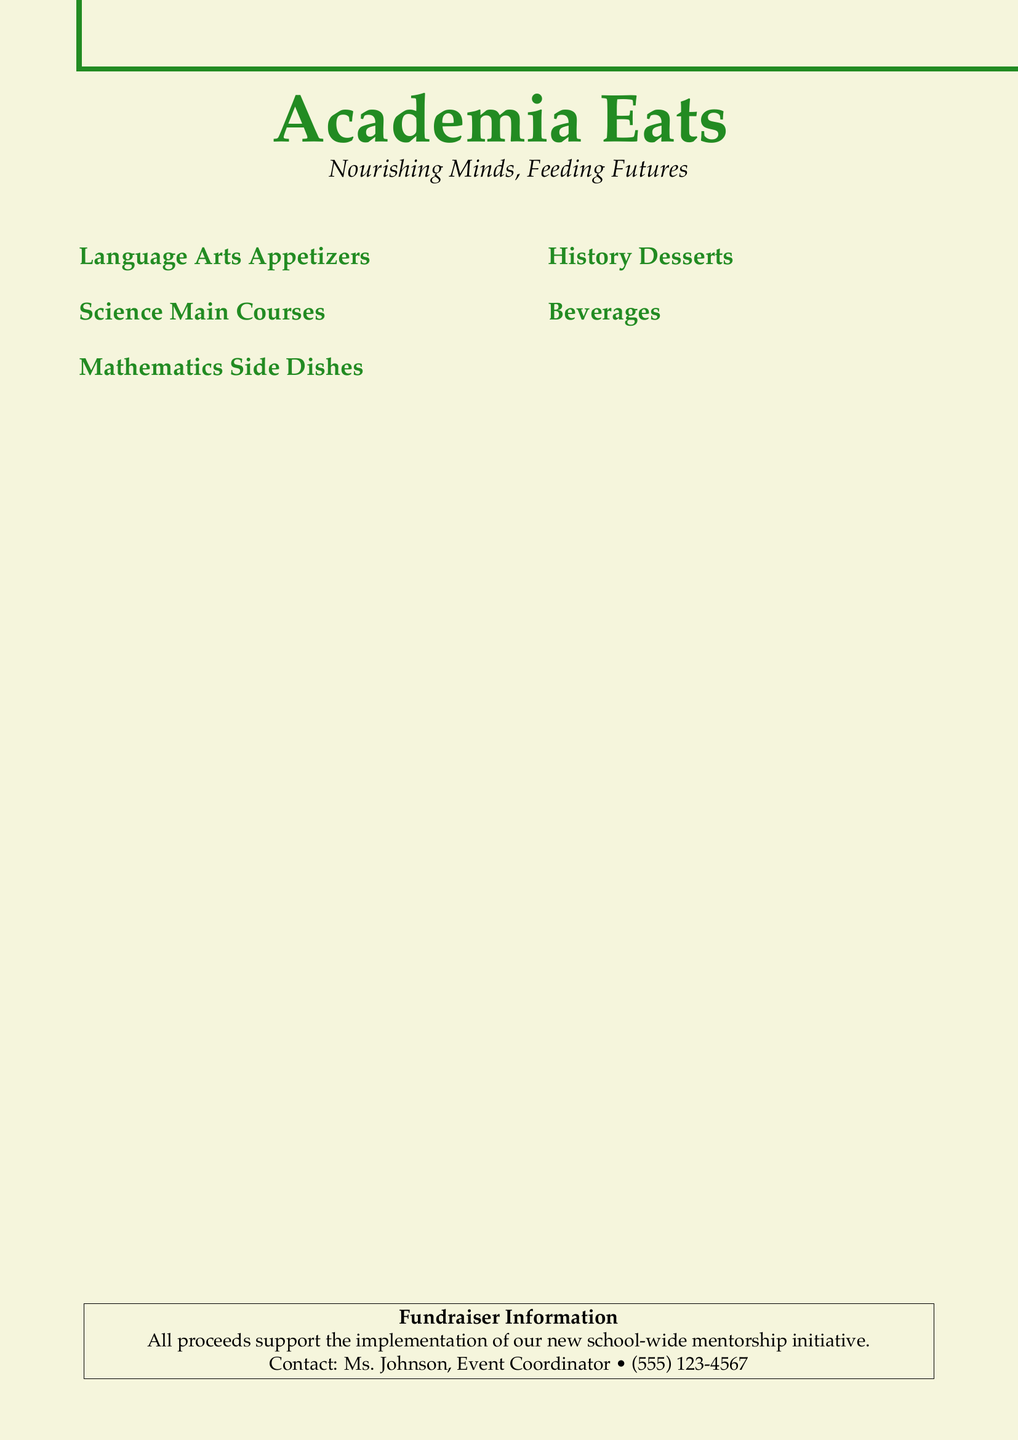What is the name of the fundraiser event? The name of the fundraiser event is displayed at the top of the document, highlighting the theme of the menu.
Answer: Academia Eats What is the price of Shakespeare's Sonnet Sampler? The price is listed next to the menu item under Language Arts Appetizers.
Answer: $8.50 What are the ingredients in Newton's Apple Pork? The ingredients are described in the menu item for Science Main Courses.
Answer: Roasted pork loin with caramelized apples and gravity-defying mashed potatoes How many main course options are there? The main course options are counted under the Science section of the menu.
Answer: 2 What format is the menu displayed in? The format refers to how the menu is structured, specifically regarding its content and layout style.
Answer: Two-column layout What drink is inspired by Socrates? The drink is named after Socrates, shown under the Beverages section.
Answer: Socrates' Soda Which dessert features a flag? The dessert is mentioned in the History section of the menu, highlighting its thematic element.
Answer: Revolutionary Red Velvet Cake What is the contact number for the event coordinator? The contact number is provided in the Fundraiser Information section at the bottom of the document.
Answer: (555) 123-4567 What kind of dish is Fibonacci Fries? This question assesses the nature of the dish described in the Mathematics section.
Answer: Side dish 